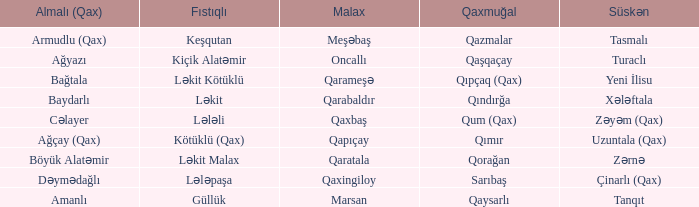What is the Almali village with the Malax village qaxingiloy? Dəymədağlı. 